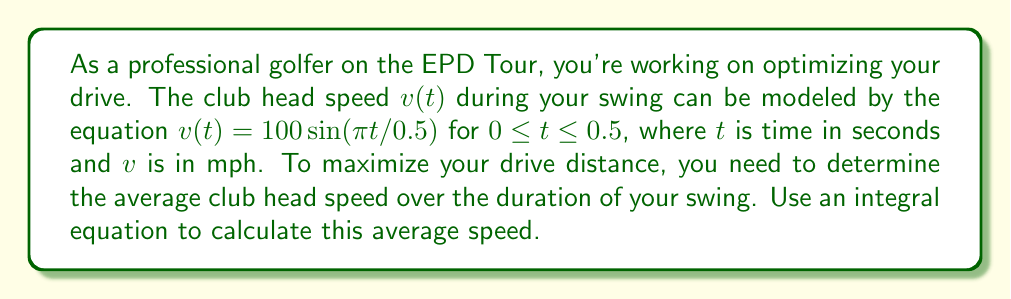Help me with this question. To solve this problem, we'll follow these steps:

1) The average speed is given by the definite integral of the velocity function divided by the time interval:

   $$\text{Average Speed} = \frac{1}{b-a}\int_{a}^{b} v(t) dt$$

   where $a=0$ and $b=0.5$ in this case.

2) Substitute the given function and limits:

   $$\text{Average Speed} = \frac{1}{0.5-0}\int_{0}^{0.5} 100\sin(\pi t/0.5) dt$$

3) Simplify:

   $$\text{Average Speed} = 2\int_{0}^{0.5} 100\sin(2\pi t) dt$$

4) To integrate, we'll use the substitution $u = 2\pi t$, $du = 2\pi dt$, $dt = du/(2\pi)$:

   $$\text{Average Speed} = 2 \cdot \frac{100}{2\pi} \int_{0}^{\pi} \sin(u) du$$

5) Integrate:

   $$\text{Average Speed} = \frac{100}{\pi} [-\cos(u)]_{0}^{\pi}$$

6) Evaluate the integral:

   $$\text{Average Speed} = \frac{100}{\pi} [-\cos(\pi) - (-\cos(0))]$$
   $$\text{Average Speed} = \frac{100}{\pi} [1 - (-1)] = \frac{200}{\pi}$$

7) Calculate the final result:

   $$\text{Average Speed} \approx 63.66 \text{ mph}$$
Answer: 63.66 mph 